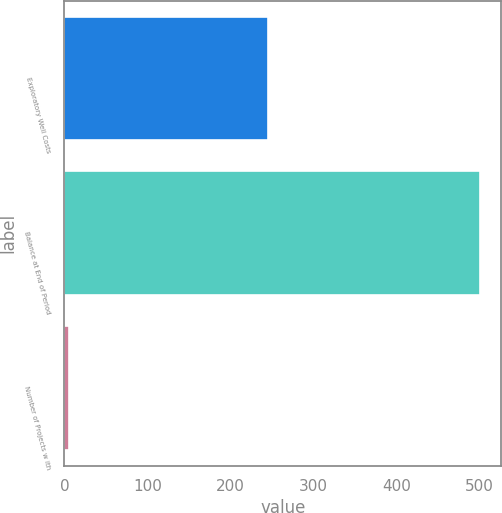<chart> <loc_0><loc_0><loc_500><loc_500><bar_chart><fcel>Exploratory Well Costs<fcel>Balance at End of Period<fcel>Number of Projects w ith<nl><fcel>245<fcel>501<fcel>6<nl></chart> 